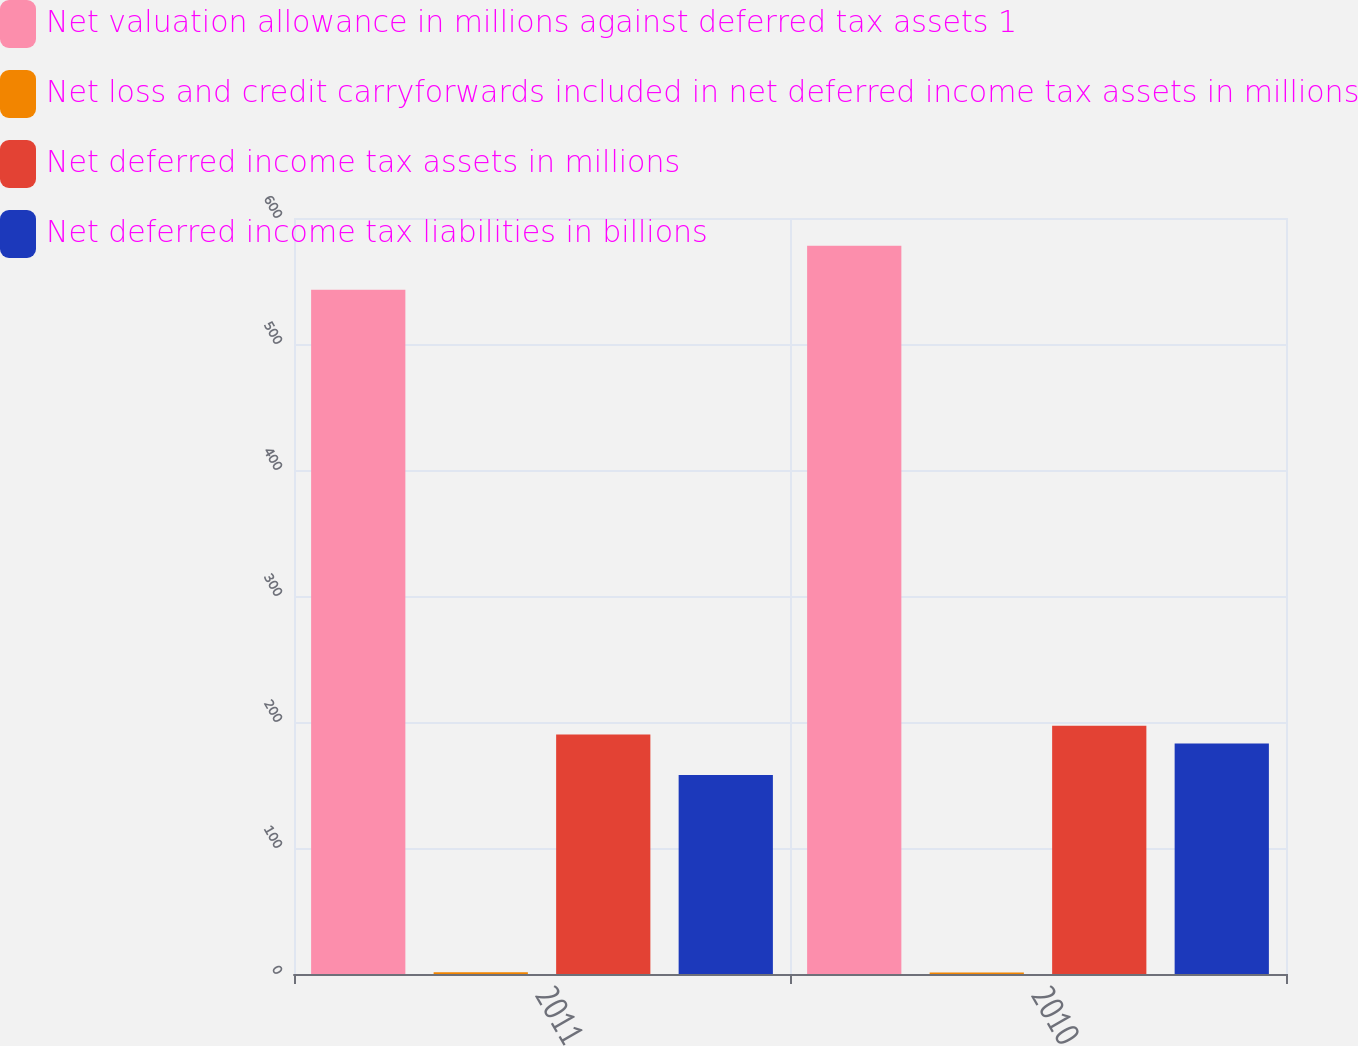<chart> <loc_0><loc_0><loc_500><loc_500><stacked_bar_chart><ecel><fcel>2011<fcel>2010<nl><fcel>Net valuation allowance in millions against deferred tax assets 1<fcel>543<fcel>578<nl><fcel>Net loss and credit carryforwards included in net deferred income tax assets in millions<fcel>1.4<fcel>1.2<nl><fcel>Net deferred income tax assets in millions<fcel>190<fcel>197<nl><fcel>Net deferred income tax liabilities in billions<fcel>158<fcel>183<nl></chart> 